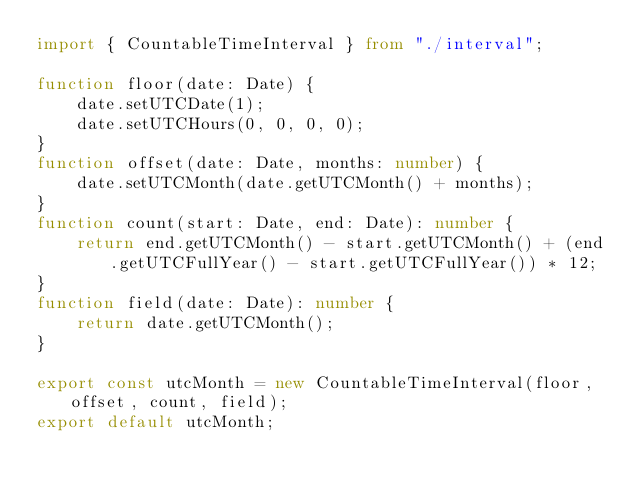Convert code to text. <code><loc_0><loc_0><loc_500><loc_500><_TypeScript_>import { CountableTimeInterval } from "./interval";

function floor(date: Date) {
    date.setUTCDate(1);
    date.setUTCHours(0, 0, 0, 0);
}
function offset(date: Date, months: number) {
    date.setUTCMonth(date.getUTCMonth() + months);
}
function count(start: Date, end: Date): number {
    return end.getUTCMonth() - start.getUTCMonth() + (end.getUTCFullYear() - start.getUTCFullYear()) * 12;
}
function field(date: Date): number {
    return date.getUTCMonth();
}

export const utcMonth = new CountableTimeInterval(floor, offset, count, field);
export default utcMonth;
</code> 